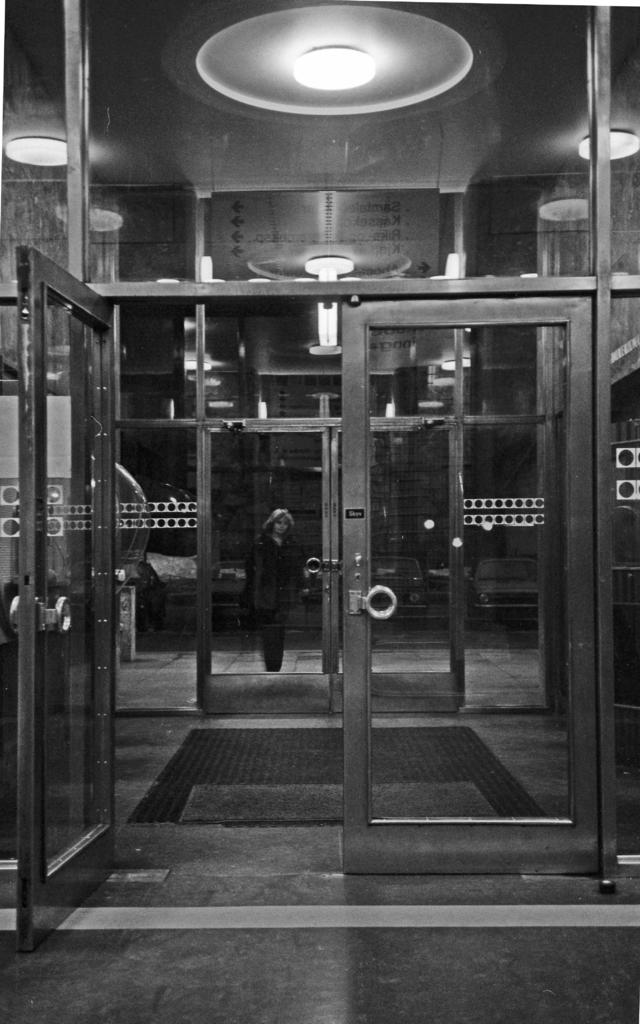What is the color scheme of the image? The image is black and white. What type of architectural feature can be seen in the image? There are doors in the image. Can you describe the person in the image? There is a person in the image. What is located at the top of the image? There are lights at the top of the image. How many chickens are visible in the image? There are no chickens present in the image. What type of blade is being used by the person in the image? There is no blade visible in the image, and the person's actions are not described. 